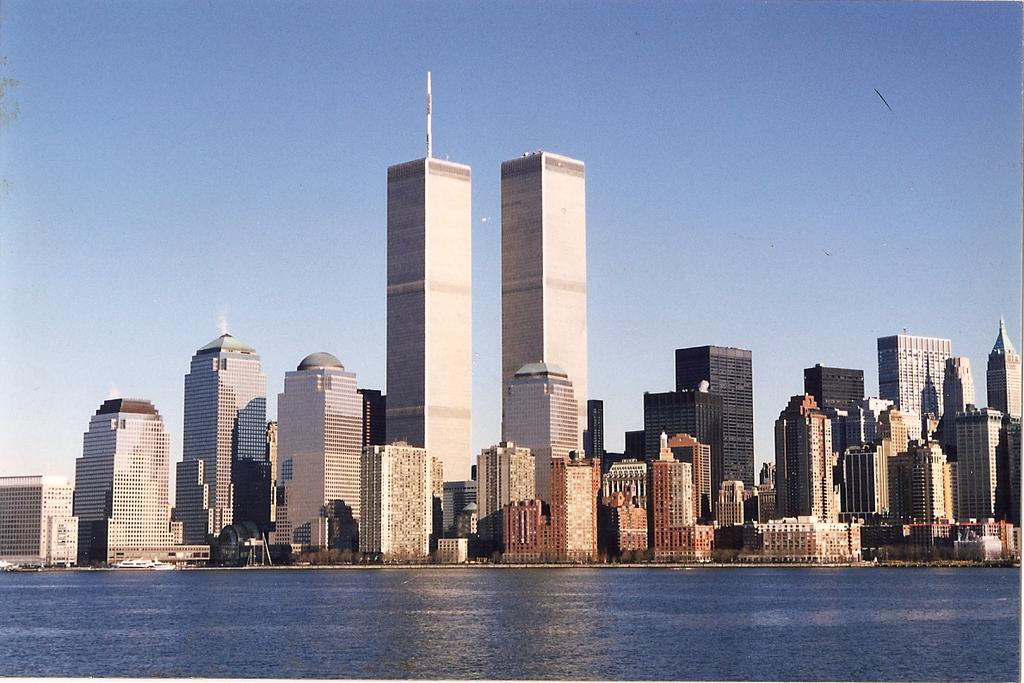What type of structures can be seen in the image? There are buildings in the image. Is there any specific feature on one of the buildings? Yes, there is a tower on one of the buildings. What can be seen in the water in the image? There are boats in the water. How would you describe the sky in the image? The sky is cloudy. What type of wax can be seen melting on the roots of the trees in the image? There are no trees or wax present in the image; it features buildings, a tower, boats, and a cloudy sky. 